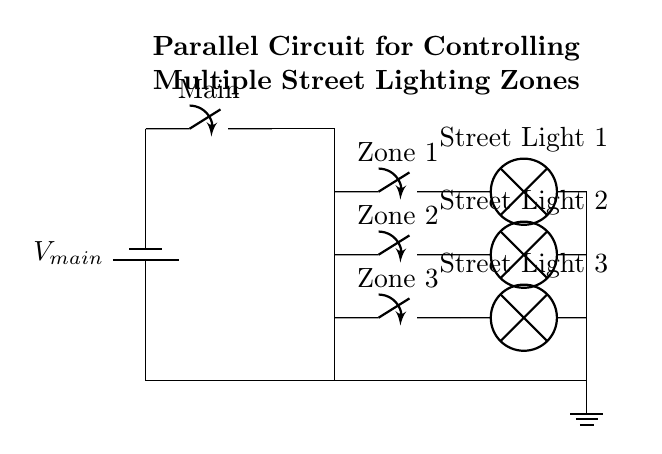What is the main power source voltage? The main power source voltage is represented as V main. Since the circuit does not specify an exact voltage, we accept it as a variable.
Answer: V main How many zones of street lighting are controlled in this circuit? The circuit diagram shows three distinct zones, indicated by the labeled switches. Each zone has its associated street light.
Answer: Three What is the function of the main switch? The main switch is used to control the entire circuit by allowing or cutting off electricity flow to all connected components, influencing every zone simultaneously.
Answer: Control multiple zones What type of circuit is depicted? This circuit is a parallel circuit, as it shows multiple branches where current can flow through different pathways simultaneously.
Answer: Parallel What happens if one street light fails? If one street light fails, the others will continue operating because they are in parallel, allowing current to bypass the faulty component.
Answer: Others remain on How many lamps are present in this circuit? The circuit includes three lamps, each located in different zones as indicated by the labels.
Answer: Three lamps What type of components are used to control the zones? The components used are switches that allow the operator to turn each street light zone on or off independently.
Answer: Switches 